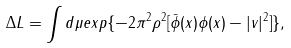Convert formula to latex. <formula><loc_0><loc_0><loc_500><loc_500>\Delta L = \int d \mu e x p \{ - 2 \pi ^ { 2 } \rho ^ { 2 } [ \bar { \phi } ( x ) \phi ( x ) - | v | ^ { 2 } ] \} ,</formula> 